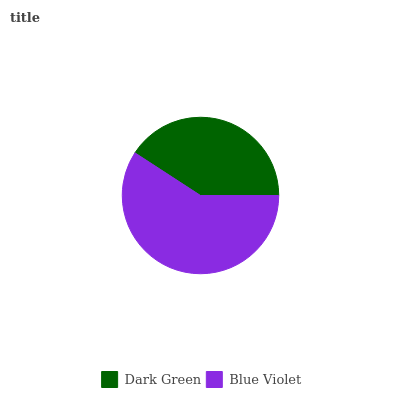Is Dark Green the minimum?
Answer yes or no. Yes. Is Blue Violet the maximum?
Answer yes or no. Yes. Is Blue Violet the minimum?
Answer yes or no. No. Is Blue Violet greater than Dark Green?
Answer yes or no. Yes. Is Dark Green less than Blue Violet?
Answer yes or no. Yes. Is Dark Green greater than Blue Violet?
Answer yes or no. No. Is Blue Violet less than Dark Green?
Answer yes or no. No. Is Blue Violet the high median?
Answer yes or no. Yes. Is Dark Green the low median?
Answer yes or no. Yes. Is Dark Green the high median?
Answer yes or no. No. Is Blue Violet the low median?
Answer yes or no. No. 